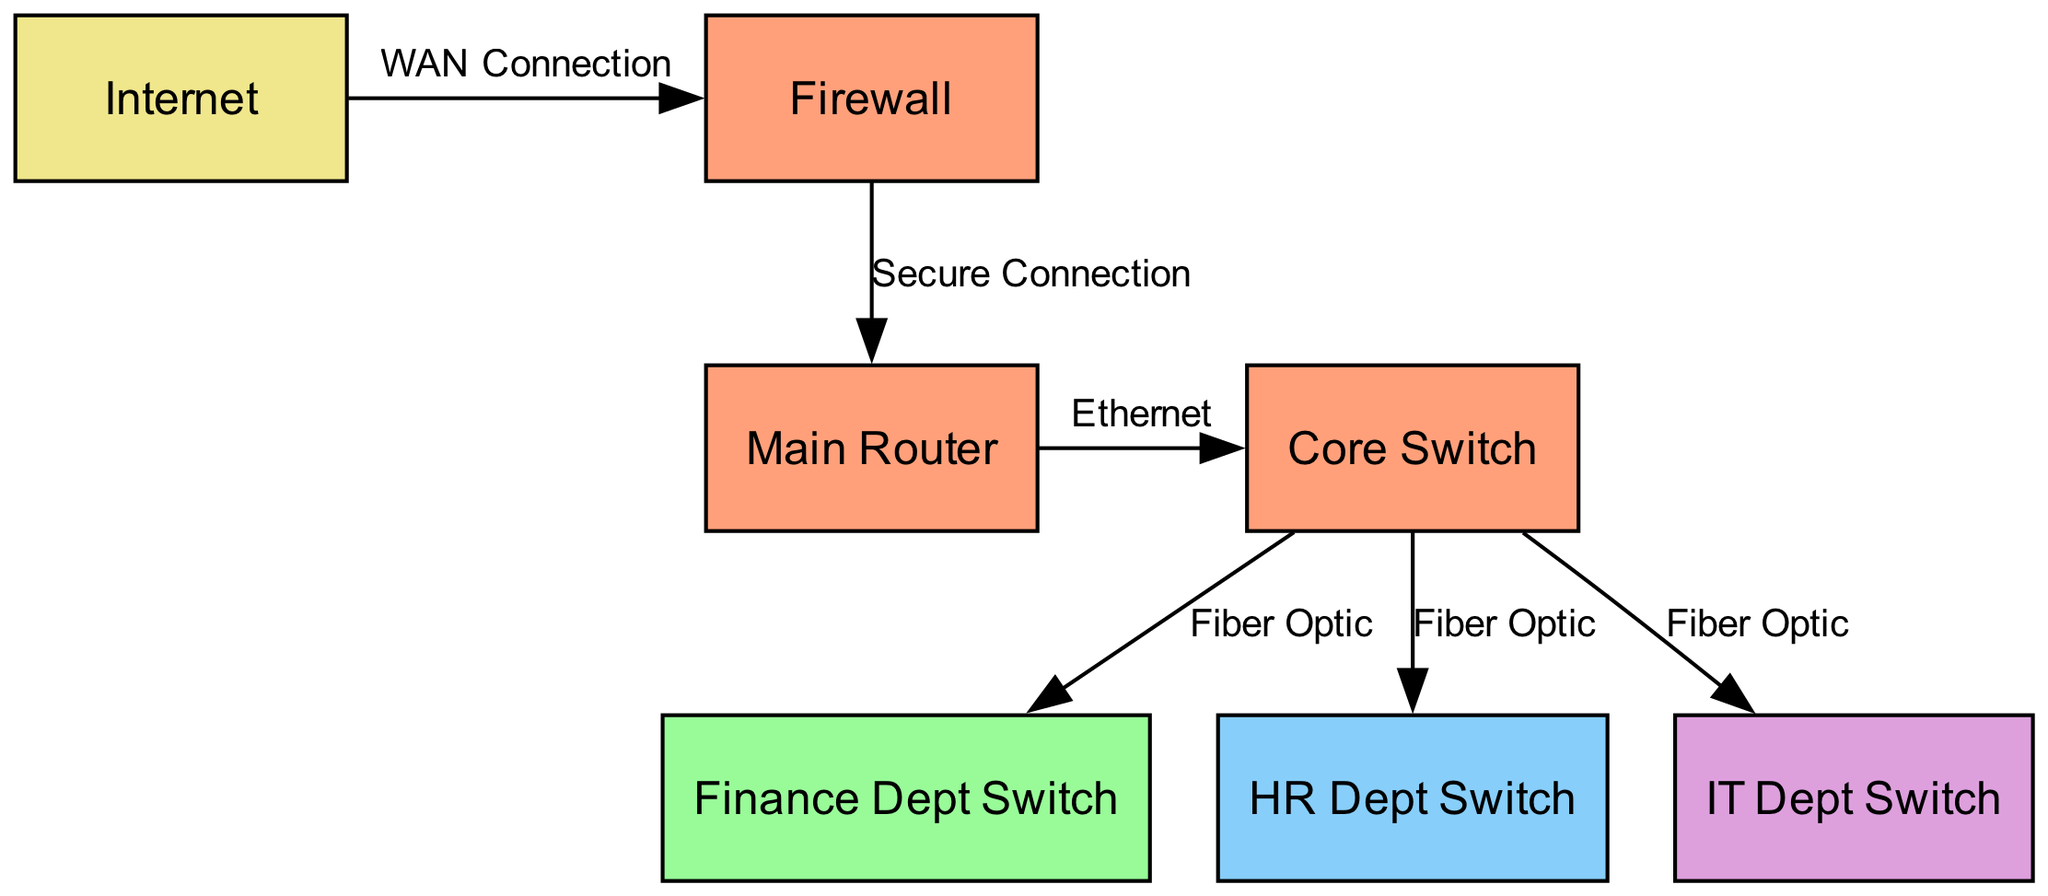What is the label of node 3? Node 3 in the diagram represents a switch for the Finance Department. This information is directly stated in the data provided for nodes.
Answer: Finance Dept Switch How many floors are represented in the diagram? The diagram features nodes on four different floors: Ground, 1st, 2nd, and 3rd. Counting these, we determine there are four distinct floors.
Answer: 4 What is the type of connection between the Main Router and the Core Switch? The connection between the Main Router (node 1) and the Core Switch (node 2) is labeled as "Ethernet," which specifies the type of connection used in the diagram.
Answer: Ethernet Which department has a switch located on the 2nd floor? According to the data for nodes, the switch located on the 2nd floor is for the HR Department. This information is gleaned from the label associated with node 4.
Answer: HR Dept Switch How many total nodes are present in the diagram? By examining the nodes listed, we find there are seven nodes present in total, including various switches and the main router.
Answer: 7 What do the edges labeled "Fiber Optic" connect? The edges labeled "Fiber Optic" connect the Core Switch (node 2) to three different department switches: the Finance Dept Switch (node 3), HR Dept Switch (node 4), and IT Dept Switch (node 5). This means there are three connections of this type.
Answer: 3 connections What is the floor location of the Firewall? In the diagram, the Firewall is indicated as being located on the Ground floor. This is derived from the data specifying the floor for node 6.
Answer: Ground Which node connects to the Internet? The only node that connects to the Internet as per the diagram is the Firewall (node 6), receiving a WAN connection from the Internet (node 7). This relationship is directly depicted in the edges.
Answer: Firewall What connections are made from the Core Switch? The Core Switch (node 2) has three outgoing connections that are all labeled as "Fiber Optic" to the Finance Dept Switch (node 3), HR Dept Switch (node 4), and IT Dept Switch (node 5). This information can be gathered by checking the edges connected to node 2.
Answer: 3 Fiber Optic connections 